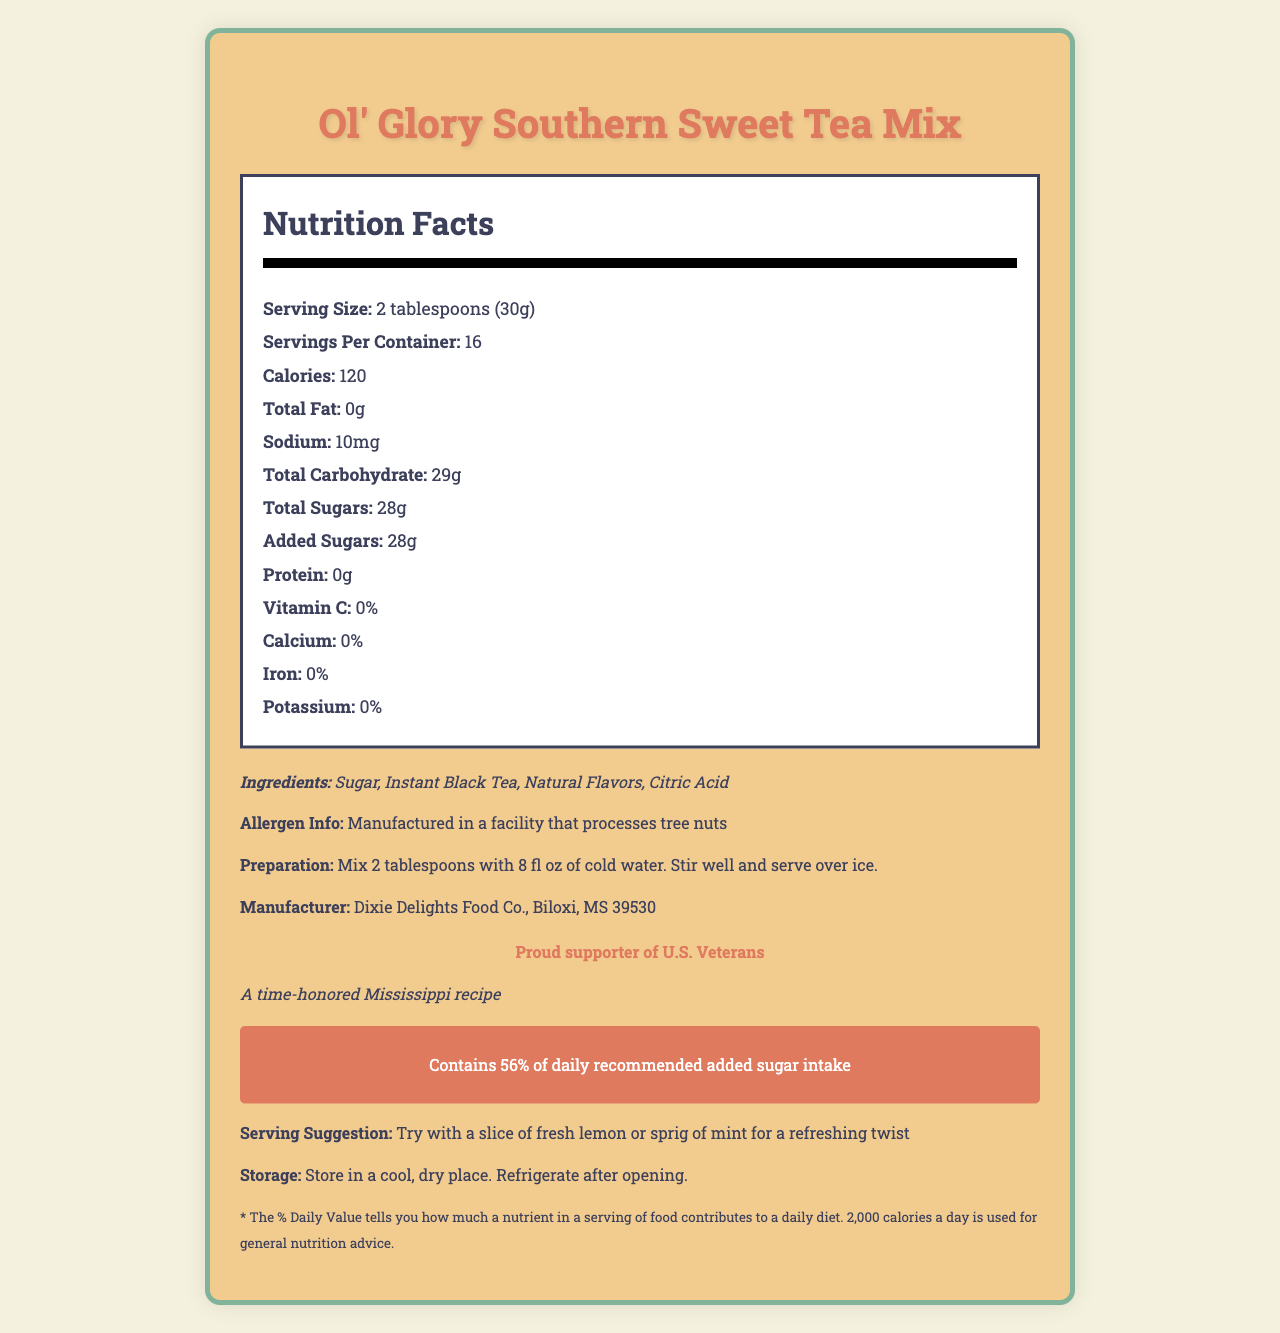How many calories are in one serving of Ol' Glory Southern Sweet Tea Mix? The document states that there are 120 calories per serving.
Answer: 120 What is the serving size for the Ol' Glory Southern Sweet Tea Mix? The document lists the serving size as 2 tablespoons, which is also 30 grams.
Answer: 2 tablespoons (30g) What percentage of daily recommended added sugar intake does one serving of this sweet tea mix contain? The document contains a warning that mentions one serving contains 56% of the daily recommended added sugar intake.
Answer: 56% How many total carbohydrates are in each serving? According to the document, there are 29 grams of total carbohydrates per serving.
Answer: 29g What is the allergen information provided for this product? The document mentions this specific allergen information.
Answer: Manufactured in a facility that processes tree nuts Which ingredient is listed first on the ingredients list? The document lists the ingredients in the following order: Sugar, Instant Black Tea, Natural Flavors, Citric Acid.
Answer: Sugar What is the geographical claim made on the document for this sweet tea mix's recipe? The document claims that the recipe is a time-honored Mississippi recipe.
Answer: A time-honored Mississippi recipe For someone watching their sodium intake, how much sodium is in one serving? The document states that each serving contains 10 milligrams of sodium.
Answer: 10mg How many total sugars are in one serving? According to the document, there are 28 grams of total sugars in each serving.
Answer: 28g What recommendation is given for enhancing the flavor with a refreshing twist? The document suggests trying the tea with a slice of fresh lemon or a sprig of mint for a refreshing twist.
Answer: Try with a slice of fresh lemon or sprig of mint Which company manufactures the Ol' Glory Southern Sweet Tea Mix? A. Gulf Coast Foods B. Dixie Delights Food Co. C. Magnolia Beverages The document specifies that the manufacturer is Dixie Delights Food Co.
Answer: B How many servings are included in the container? A. 10 B. 12 C. 16 D. 18 The document states that there are 16 servings per container.
Answer: C Does this sweet tea mix contain any protein? The document states that there are 0 grams of protein per serving, so the answer is no.
Answer: No Are there any vitamins or minerals like Vitamin C, Calcium, Iron, or Potassium in the product? The document indicates that there are 0% of the daily value for Vitamin C, Calcium, Iron, and Potassium.
Answer: No Summarize the main details provided in the document about Ol' Glory Southern Sweet Tea Mix. This summary provides a comprehensive overview of the key details from the document, including nutritional values, ingredients, manufacturer information, and special claims.
Answer: Ol' Glory Southern Sweet Tea Mix contains 120 calories per serving, with a serving size of 2 tablespoons (30g). Each serving has 0g fat, 10mg sodium, 29g total carbohydrates, 28g total sugars (all added sugars), and 0g protein. The product includes ingredients such as sugar, instant black tea, natural flavors, and citric acid, and is manufactured by Dixie Delights Food Co. in Biloxi, MS. It has a Southern heritage claim of being a time-honored Mississippi recipe and comes with a sugar content warning indicating it contains 56% of the daily recommended added sugar intake. The mix is manufactured in a facility that processes tree nuts. What is the exact amount of natural flavors used in the mix? The document lists natural flavors as an ingredient but does not specify the exact amount used.
Answer: Cannot be determined 